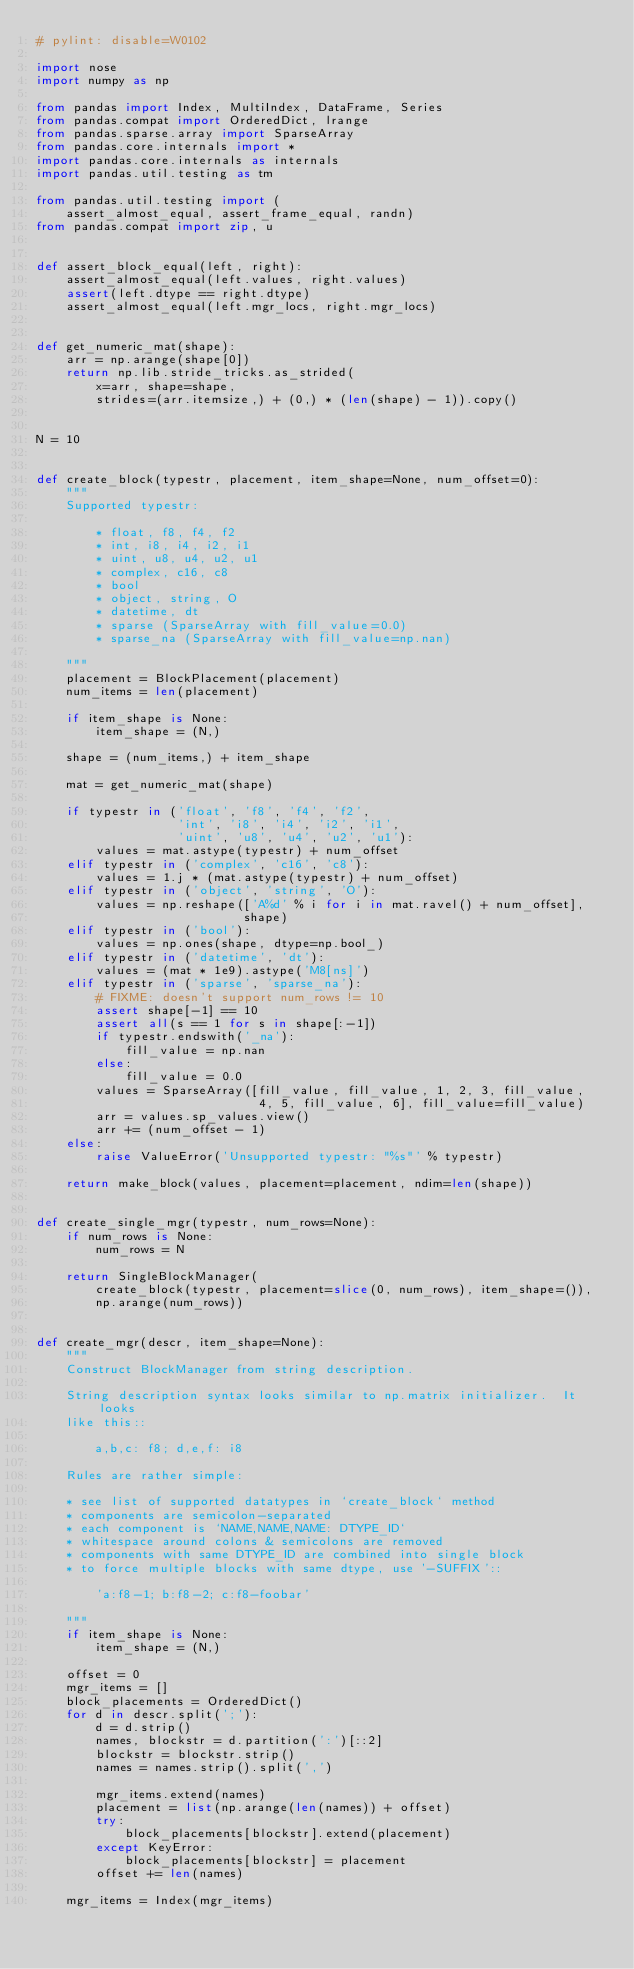Convert code to text. <code><loc_0><loc_0><loc_500><loc_500><_Python_># pylint: disable=W0102

import nose
import numpy as np

from pandas import Index, MultiIndex, DataFrame, Series
from pandas.compat import OrderedDict, lrange
from pandas.sparse.array import SparseArray
from pandas.core.internals import *
import pandas.core.internals as internals
import pandas.util.testing as tm

from pandas.util.testing import (
    assert_almost_equal, assert_frame_equal, randn)
from pandas.compat import zip, u


def assert_block_equal(left, right):
    assert_almost_equal(left.values, right.values)
    assert(left.dtype == right.dtype)
    assert_almost_equal(left.mgr_locs, right.mgr_locs)


def get_numeric_mat(shape):
    arr = np.arange(shape[0])
    return np.lib.stride_tricks.as_strided(
        x=arr, shape=shape,
        strides=(arr.itemsize,) + (0,) * (len(shape) - 1)).copy()


N = 10


def create_block(typestr, placement, item_shape=None, num_offset=0):
    """
    Supported typestr:

        * float, f8, f4, f2
        * int, i8, i4, i2, i1
        * uint, u8, u4, u2, u1
        * complex, c16, c8
        * bool
        * object, string, O
        * datetime, dt
        * sparse (SparseArray with fill_value=0.0)
        * sparse_na (SparseArray with fill_value=np.nan)

    """
    placement = BlockPlacement(placement)
    num_items = len(placement)

    if item_shape is None:
        item_shape = (N,)

    shape = (num_items,) + item_shape

    mat = get_numeric_mat(shape)

    if typestr in ('float', 'f8', 'f4', 'f2',
                   'int', 'i8', 'i4', 'i2', 'i1',
                   'uint', 'u8', 'u4', 'u2', 'u1'):
        values = mat.astype(typestr) + num_offset
    elif typestr in ('complex', 'c16', 'c8'):
        values = 1.j * (mat.astype(typestr) + num_offset)
    elif typestr in ('object', 'string', 'O'):
        values = np.reshape(['A%d' % i for i in mat.ravel() + num_offset],
                            shape)
    elif typestr in ('bool'):
        values = np.ones(shape, dtype=np.bool_)
    elif typestr in ('datetime', 'dt'):
        values = (mat * 1e9).astype('M8[ns]')
    elif typestr in ('sparse', 'sparse_na'):
        # FIXME: doesn't support num_rows != 10
        assert shape[-1] == 10
        assert all(s == 1 for s in shape[:-1])
        if typestr.endswith('_na'):
            fill_value = np.nan
        else:
            fill_value = 0.0
        values = SparseArray([fill_value, fill_value, 1, 2, 3, fill_value,
                              4, 5, fill_value, 6], fill_value=fill_value)
        arr = values.sp_values.view()
        arr += (num_offset - 1)
    else:
        raise ValueError('Unsupported typestr: "%s"' % typestr)

    return make_block(values, placement=placement, ndim=len(shape))


def create_single_mgr(typestr, num_rows=None):
    if num_rows is None:
        num_rows = N

    return SingleBlockManager(
        create_block(typestr, placement=slice(0, num_rows), item_shape=()),
        np.arange(num_rows))


def create_mgr(descr, item_shape=None):
    """
    Construct BlockManager from string description.

    String description syntax looks similar to np.matrix initializer.  It looks
    like this::

        a,b,c: f8; d,e,f: i8

    Rules are rather simple:

    * see list of supported datatypes in `create_block` method
    * components are semicolon-separated
    * each component is `NAME,NAME,NAME: DTYPE_ID`
    * whitespace around colons & semicolons are removed
    * components with same DTYPE_ID are combined into single block
    * to force multiple blocks with same dtype, use '-SUFFIX'::

        'a:f8-1; b:f8-2; c:f8-foobar'

    """
    if item_shape is None:
        item_shape = (N,)

    offset = 0
    mgr_items = []
    block_placements = OrderedDict()
    for d in descr.split(';'):
        d = d.strip()
        names, blockstr = d.partition(':')[::2]
        blockstr = blockstr.strip()
        names = names.strip().split(',')

        mgr_items.extend(names)
        placement = list(np.arange(len(names)) + offset)
        try:
            block_placements[blockstr].extend(placement)
        except KeyError:
            block_placements[blockstr] = placement
        offset += len(names)

    mgr_items = Index(mgr_items)
</code> 